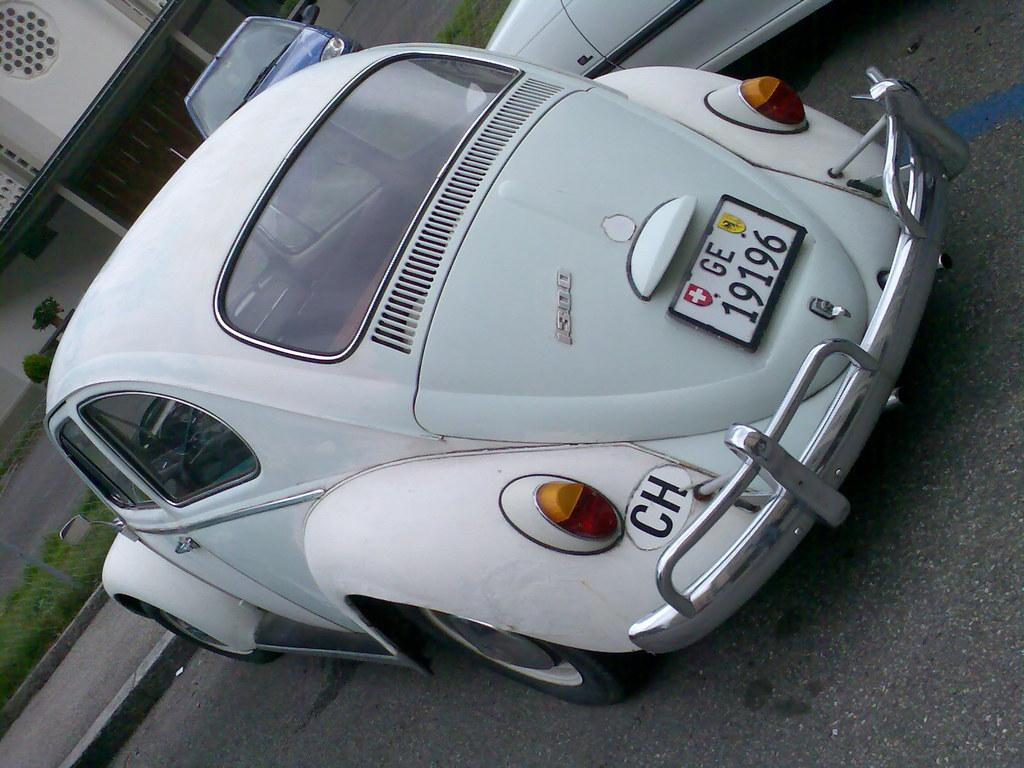What can be seen on the road in the image? There are cars on the road in the image. What type of barrier is present in the image? There is a fence in the image. What type of vegetation is visible in the image? There is grass in the image. What can be seen in the background of the image? There is a wall, a door, and plants in the background of the image. How many girls are playing with the pets in the image? There are no girls or pets present in the image. What achievement is the achiever celebrating in the image? There is no achiever or celebration of an achievement depicted in the image. 